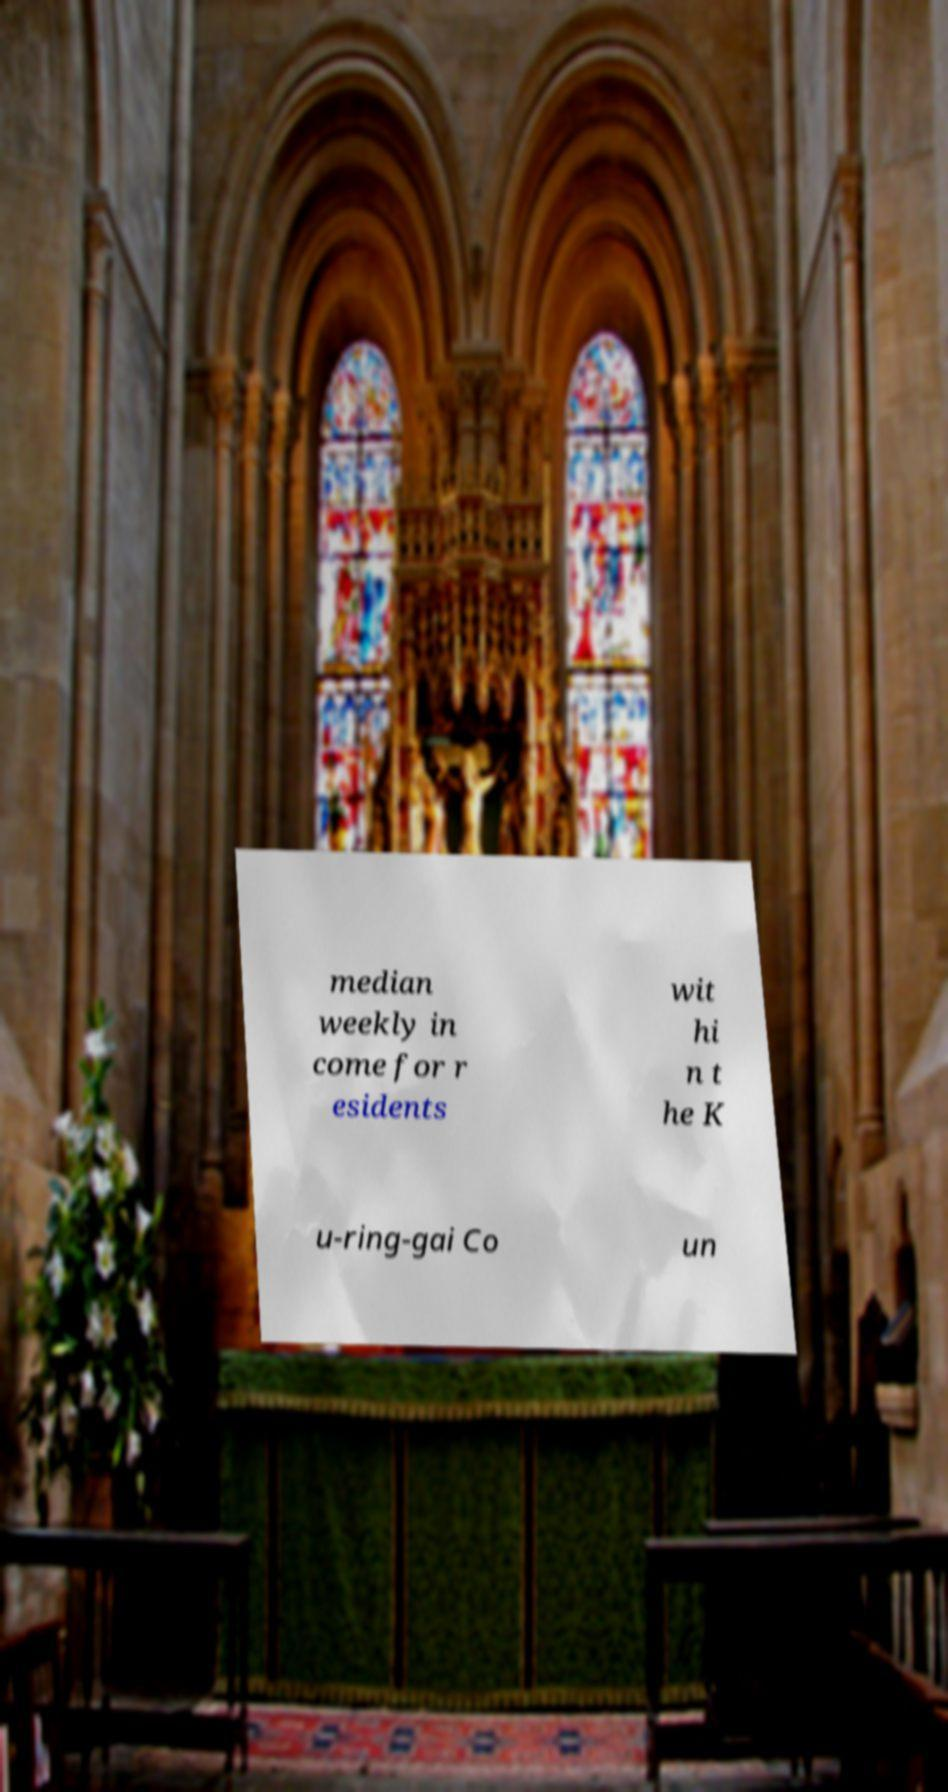Can you accurately transcribe the text from the provided image for me? median weekly in come for r esidents wit hi n t he K u-ring-gai Co un 